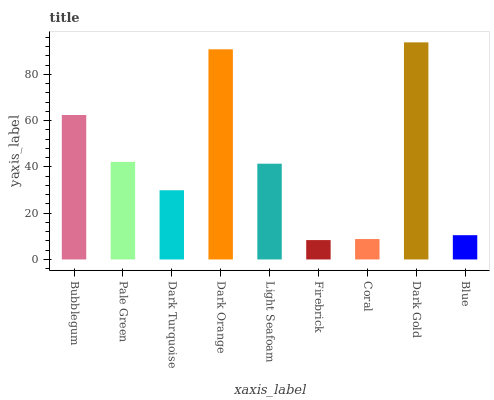Is Firebrick the minimum?
Answer yes or no. Yes. Is Dark Gold the maximum?
Answer yes or no. Yes. Is Pale Green the minimum?
Answer yes or no. No. Is Pale Green the maximum?
Answer yes or no. No. Is Bubblegum greater than Pale Green?
Answer yes or no. Yes. Is Pale Green less than Bubblegum?
Answer yes or no. Yes. Is Pale Green greater than Bubblegum?
Answer yes or no. No. Is Bubblegum less than Pale Green?
Answer yes or no. No. Is Light Seafoam the high median?
Answer yes or no. Yes. Is Light Seafoam the low median?
Answer yes or no. Yes. Is Dark Gold the high median?
Answer yes or no. No. Is Coral the low median?
Answer yes or no. No. 